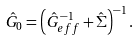Convert formula to latex. <formula><loc_0><loc_0><loc_500><loc_500>\hat { G } _ { 0 } = \left ( \hat { G } _ { e f f } ^ { - 1 } + \hat { \Sigma } \right ) ^ { - 1 } .</formula> 